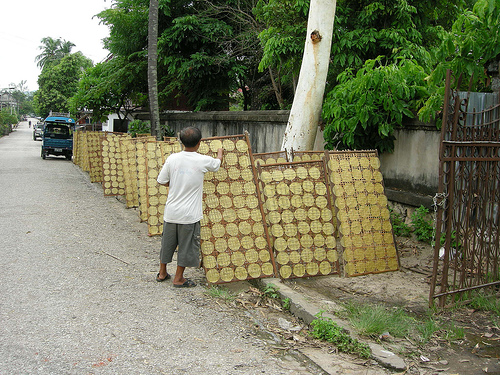<image>
Is there a men under the tree? Yes. The men is positioned underneath the tree, with the tree above it in the vertical space. 